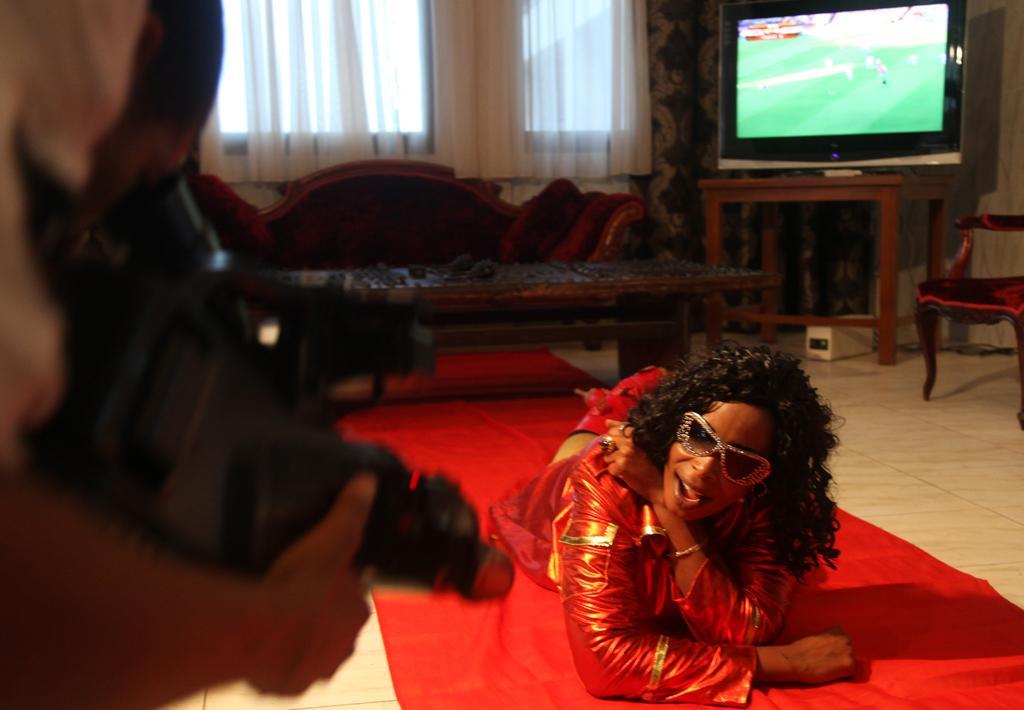Please provide a concise description of this image. In this image in the center there is one person who is laying, on the right side there is another person who is holding a camera and in the background there is one couch, table, television and one chair. And on the top of the image there is window and some curtains. 